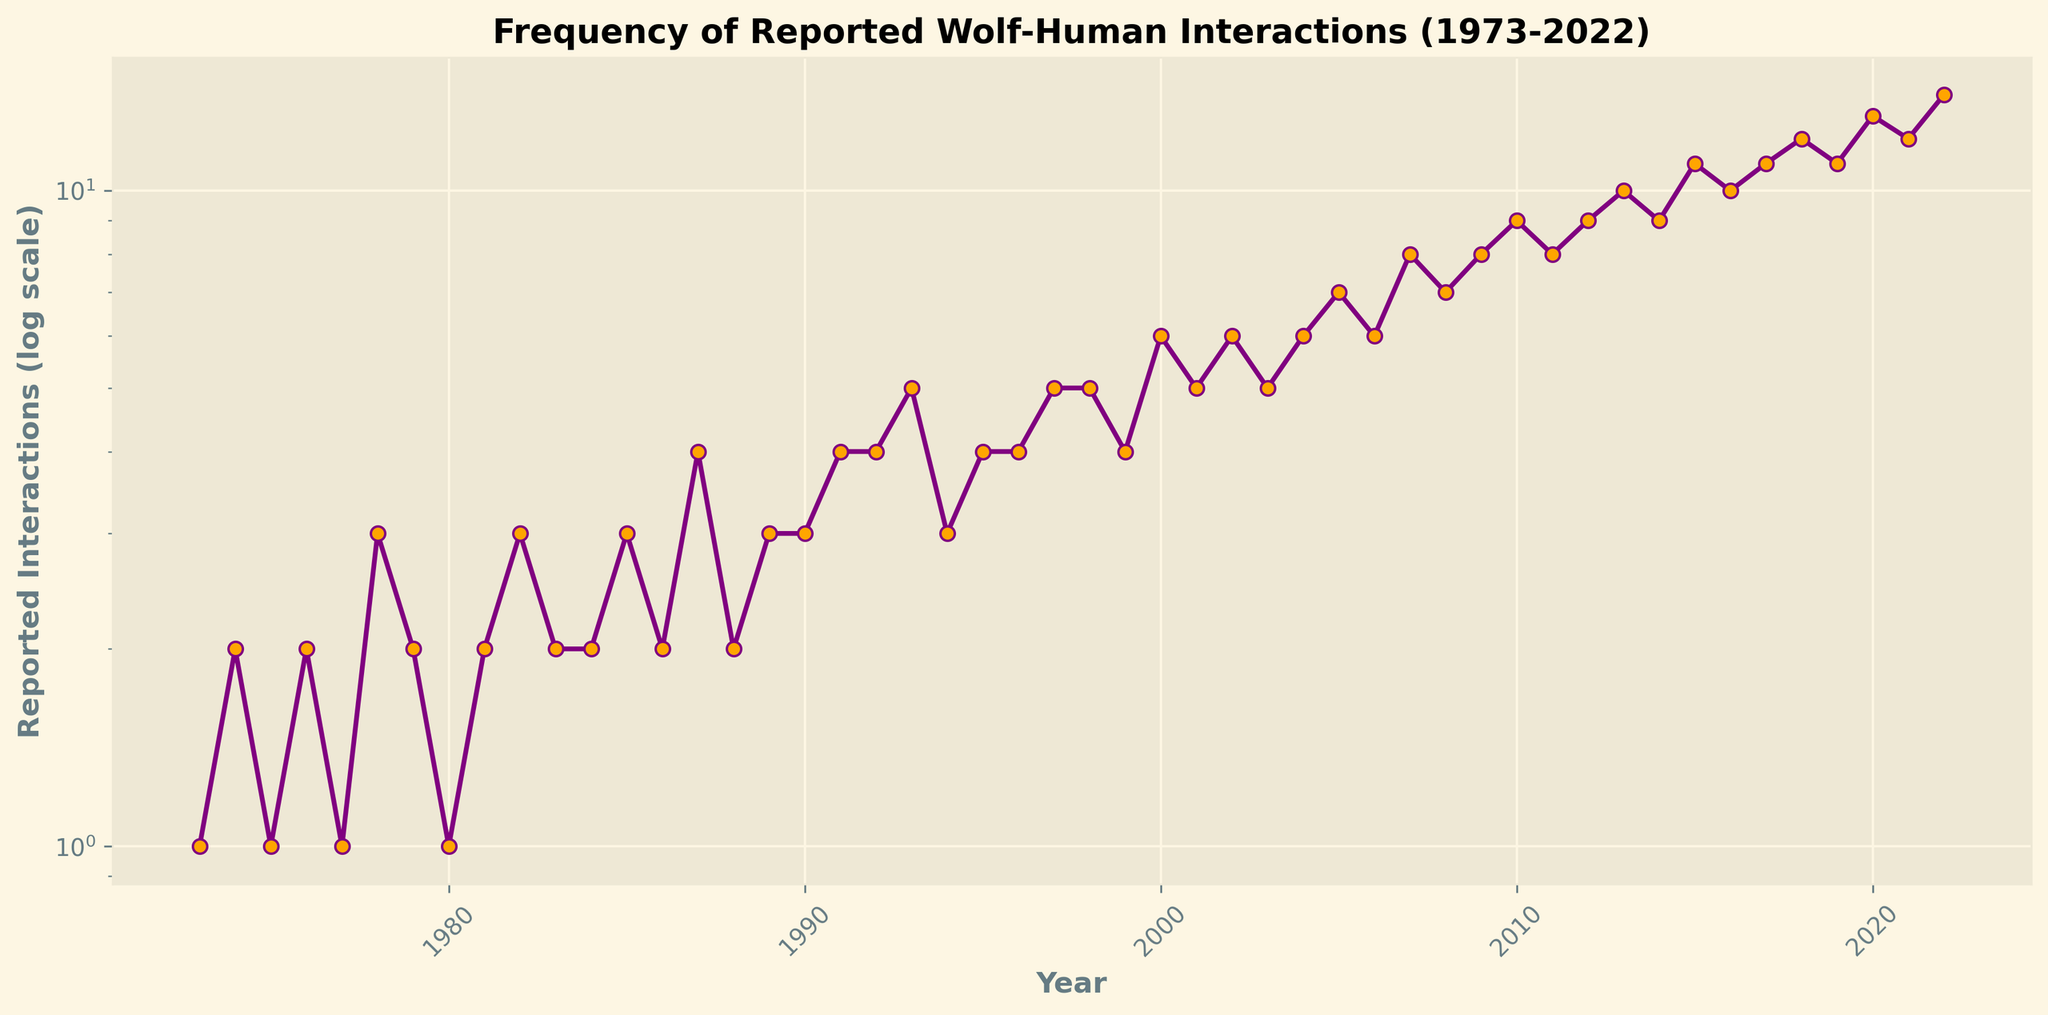What is the range of the reported interactions in the dataset? The minimum value for Reported Interactions is 1 (in 1973, 1975, 1977, 1980) and the maximum value is 14 (in 2022). The range is the difference between the maximum and minimum values.
Answer: 13 Which year had the highest number of reported wolf-human interactions? By looking for the maximum value on the y-axis, we see that the year with the highest number of reported interactions is 2022, with 14 interactions.
Answer: 2022 What is the average number of reported interactions in the last decade? To find the average, sum the reported interactions from 2013 to 2022 (10 years), and divide by 10: \( (10 + 9 + 11 + 10 + 11 + 12 + 11 + 13 + 12 + 14) / 10 = 113 / 10 \).
Answer: 11.3 How many times did the frequency of reported interactions double from 1980 to 2022? Starting from 1980 with a value of 1, the frequency doubled for the first time when it reached 2 (1981). It doubled again when reaching 4 (1987), then 8 (2007), and finally 16 (though it did not reach 16 within the dataset). So, it doubled 3 times: 2, 4, and 8.
Answer: 3 What can be said about the trend in wolf-human interactions over the 50-year period? The trend shows a general increase in the number of reported wolf-human interactions. Initially, the frequency was low, with values fluctuating between 1-4 in the earlier years. From around 2000 onwards, there is a noticeable steady increase in the number of reported interactions.
Answer: Increasing trend When did the number of reported interactions consistently reach or exceed 10? The graph indicates that from 2013 onwards, the number of reported wolf-human interactions reaches or exceeds 10 consistently every year.
Answer: 2013 Which decade experienced the most significant increase in frequency of reported interactions? By comparing the decadal differences, the most significant increase occurs between 2010 and 2020. The values start from an average of around 8-9 interactions in early 2010 and reach up to 13-14 by 2020.
Answer: 2010-2020 How does the change in reported interactions from 2000 to 2020 compare to the change from 1980 to 2000? From 1980 to 2000, reported interactions increased from 1 to 6, a difference of 5. From 2000 to 2020, they increased from 6 to 13, a difference of 7. Thus, the increase is larger from 2000 to 2020.
Answer: Larger increase from 2000 to 2020 Are there any years where the frequency of reported interactions stayed constant? If so, which years? Close examination shows that reported interactions stayed constant for the following years: 1983-1984, 1989-1990, 2011-2012, and 2017-2018 with respective values of 2, 3, 8, and 11.
Answer: 1983-1984, 1989-1990, 2011-2012, 2017-2018 How do the reported interactions in the year 1980 compare to the year 2020? Reported interactions in 1980 were 1, while in 2020 they were 13. This shows an increase by a factor of 13 in 40 years.
Answer: Increased by a factor of 13 